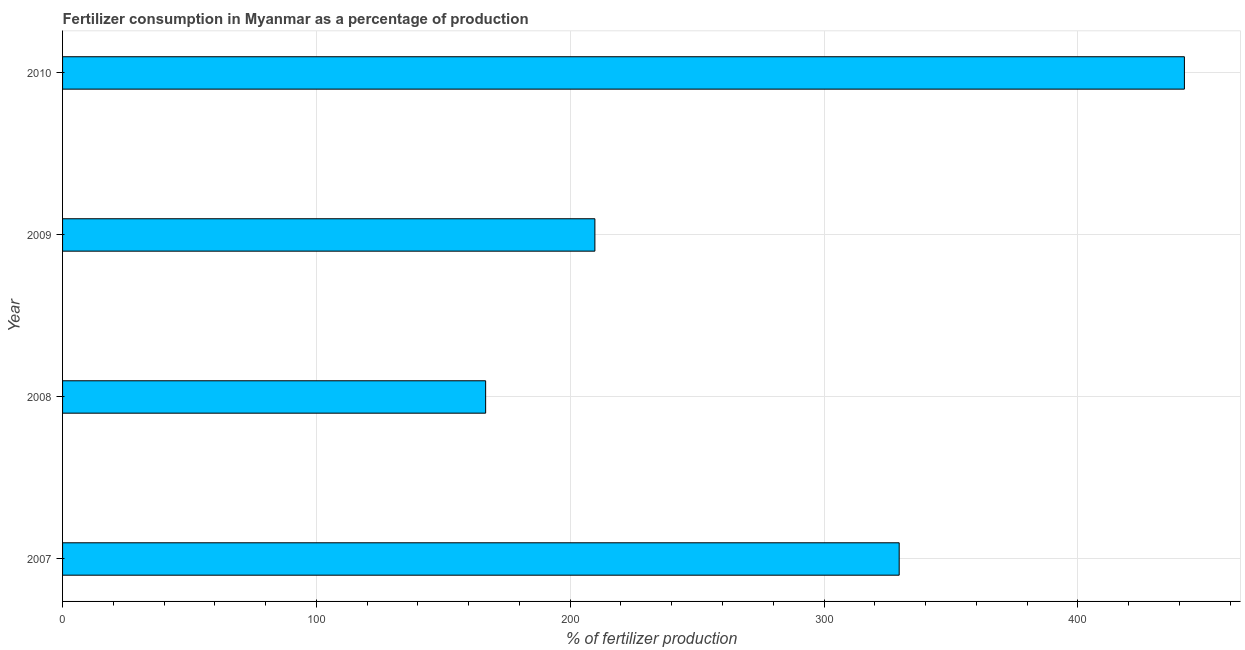Does the graph contain grids?
Your answer should be compact. Yes. What is the title of the graph?
Your answer should be compact. Fertilizer consumption in Myanmar as a percentage of production. What is the label or title of the X-axis?
Ensure brevity in your answer.  % of fertilizer production. What is the label or title of the Y-axis?
Make the answer very short. Year. What is the amount of fertilizer consumption in 2010?
Ensure brevity in your answer.  441.98. Across all years, what is the maximum amount of fertilizer consumption?
Offer a very short reply. 441.98. Across all years, what is the minimum amount of fertilizer consumption?
Your response must be concise. 166.68. In which year was the amount of fertilizer consumption minimum?
Offer a terse response. 2008. What is the sum of the amount of fertilizer consumption?
Provide a short and direct response. 1148. What is the difference between the amount of fertilizer consumption in 2008 and 2009?
Your answer should be compact. -43.05. What is the average amount of fertilizer consumption per year?
Keep it short and to the point. 287. What is the median amount of fertilizer consumption?
Your answer should be very brief. 269.67. Do a majority of the years between 2008 and 2007 (inclusive) have amount of fertilizer consumption greater than 140 %?
Your answer should be very brief. No. What is the ratio of the amount of fertilizer consumption in 2007 to that in 2008?
Keep it short and to the point. 1.98. Is the amount of fertilizer consumption in 2007 less than that in 2009?
Provide a succinct answer. No. What is the difference between the highest and the second highest amount of fertilizer consumption?
Give a very brief answer. 112.36. Is the sum of the amount of fertilizer consumption in 2009 and 2010 greater than the maximum amount of fertilizer consumption across all years?
Provide a succinct answer. Yes. What is the difference between the highest and the lowest amount of fertilizer consumption?
Keep it short and to the point. 275.3. In how many years, is the amount of fertilizer consumption greater than the average amount of fertilizer consumption taken over all years?
Provide a short and direct response. 2. How many bars are there?
Ensure brevity in your answer.  4. How many years are there in the graph?
Your response must be concise. 4. What is the difference between two consecutive major ticks on the X-axis?
Ensure brevity in your answer.  100. What is the % of fertilizer production of 2007?
Ensure brevity in your answer.  329.61. What is the % of fertilizer production in 2008?
Provide a succinct answer. 166.68. What is the % of fertilizer production in 2009?
Offer a terse response. 209.73. What is the % of fertilizer production in 2010?
Offer a very short reply. 441.98. What is the difference between the % of fertilizer production in 2007 and 2008?
Offer a very short reply. 162.93. What is the difference between the % of fertilizer production in 2007 and 2009?
Your answer should be compact. 119.89. What is the difference between the % of fertilizer production in 2007 and 2010?
Your answer should be compact. -112.36. What is the difference between the % of fertilizer production in 2008 and 2009?
Ensure brevity in your answer.  -43.05. What is the difference between the % of fertilizer production in 2008 and 2010?
Your answer should be compact. -275.3. What is the difference between the % of fertilizer production in 2009 and 2010?
Your answer should be very brief. -232.25. What is the ratio of the % of fertilizer production in 2007 to that in 2008?
Keep it short and to the point. 1.98. What is the ratio of the % of fertilizer production in 2007 to that in 2009?
Your answer should be very brief. 1.57. What is the ratio of the % of fertilizer production in 2007 to that in 2010?
Your answer should be very brief. 0.75. What is the ratio of the % of fertilizer production in 2008 to that in 2009?
Ensure brevity in your answer.  0.8. What is the ratio of the % of fertilizer production in 2008 to that in 2010?
Your answer should be very brief. 0.38. What is the ratio of the % of fertilizer production in 2009 to that in 2010?
Offer a terse response. 0.47. 